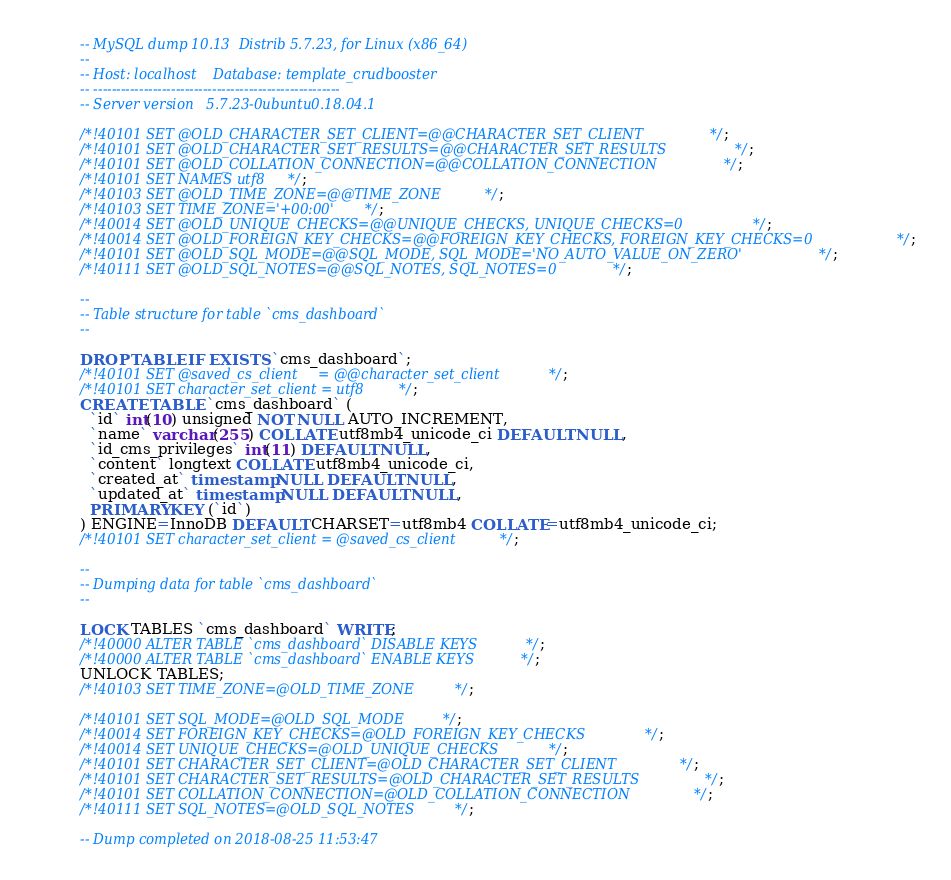Convert code to text. <code><loc_0><loc_0><loc_500><loc_500><_SQL_>-- MySQL dump 10.13  Distrib 5.7.23, for Linux (x86_64)
--
-- Host: localhost    Database: template_crudbooster
-- ------------------------------------------------------
-- Server version	5.7.23-0ubuntu0.18.04.1

/*!40101 SET @OLD_CHARACTER_SET_CLIENT=@@CHARACTER_SET_CLIENT */;
/*!40101 SET @OLD_CHARACTER_SET_RESULTS=@@CHARACTER_SET_RESULTS */;
/*!40101 SET @OLD_COLLATION_CONNECTION=@@COLLATION_CONNECTION */;
/*!40101 SET NAMES utf8 */;
/*!40103 SET @OLD_TIME_ZONE=@@TIME_ZONE */;
/*!40103 SET TIME_ZONE='+00:00' */;
/*!40014 SET @OLD_UNIQUE_CHECKS=@@UNIQUE_CHECKS, UNIQUE_CHECKS=0 */;
/*!40014 SET @OLD_FOREIGN_KEY_CHECKS=@@FOREIGN_KEY_CHECKS, FOREIGN_KEY_CHECKS=0 */;
/*!40101 SET @OLD_SQL_MODE=@@SQL_MODE, SQL_MODE='NO_AUTO_VALUE_ON_ZERO' */;
/*!40111 SET @OLD_SQL_NOTES=@@SQL_NOTES, SQL_NOTES=0 */;

--
-- Table structure for table `cms_dashboard`
--

DROP TABLE IF EXISTS `cms_dashboard`;
/*!40101 SET @saved_cs_client     = @@character_set_client */;
/*!40101 SET character_set_client = utf8 */;
CREATE TABLE `cms_dashboard` (
  `id` int(10) unsigned NOT NULL AUTO_INCREMENT,
  `name` varchar(255) COLLATE utf8mb4_unicode_ci DEFAULT NULL,
  `id_cms_privileges` int(11) DEFAULT NULL,
  `content` longtext COLLATE utf8mb4_unicode_ci,
  `created_at` timestamp NULL DEFAULT NULL,
  `updated_at` timestamp NULL DEFAULT NULL,
  PRIMARY KEY (`id`)
) ENGINE=InnoDB DEFAULT CHARSET=utf8mb4 COLLATE=utf8mb4_unicode_ci;
/*!40101 SET character_set_client = @saved_cs_client */;

--
-- Dumping data for table `cms_dashboard`
--

LOCK TABLES `cms_dashboard` WRITE;
/*!40000 ALTER TABLE `cms_dashboard` DISABLE KEYS */;
/*!40000 ALTER TABLE `cms_dashboard` ENABLE KEYS */;
UNLOCK TABLES;
/*!40103 SET TIME_ZONE=@OLD_TIME_ZONE */;

/*!40101 SET SQL_MODE=@OLD_SQL_MODE */;
/*!40014 SET FOREIGN_KEY_CHECKS=@OLD_FOREIGN_KEY_CHECKS */;
/*!40014 SET UNIQUE_CHECKS=@OLD_UNIQUE_CHECKS */;
/*!40101 SET CHARACTER_SET_CLIENT=@OLD_CHARACTER_SET_CLIENT */;
/*!40101 SET CHARACTER_SET_RESULTS=@OLD_CHARACTER_SET_RESULTS */;
/*!40101 SET COLLATION_CONNECTION=@OLD_COLLATION_CONNECTION */;
/*!40111 SET SQL_NOTES=@OLD_SQL_NOTES */;

-- Dump completed on 2018-08-25 11:53:47
</code> 